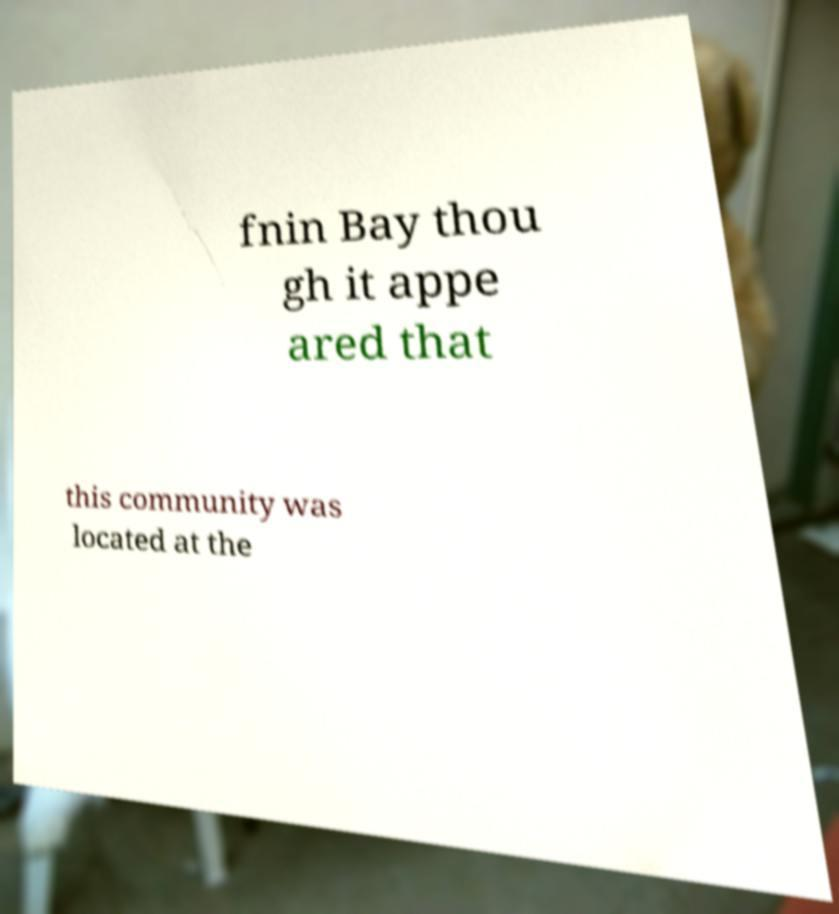Can you accurately transcribe the text from the provided image for me? fnin Bay thou gh it appe ared that this community was located at the 